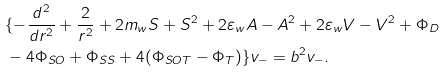<formula> <loc_0><loc_0><loc_500><loc_500>& \{ - \frac { d ^ { 2 } } { d r ^ { 2 } } + \frac { 2 } { r ^ { 2 } } + 2 m _ { w } S + S ^ { 2 } + 2 \varepsilon _ { w } A - A ^ { 2 } + 2 \varepsilon _ { w } V - V ^ { 2 } + \Phi _ { D } \\ & - 4 \Phi _ { S O } + \Phi _ { S S } + 4 ( \Phi _ { S O T } - \Phi _ { T } ) \} v _ { - } = b ^ { 2 } v _ { - } .</formula> 